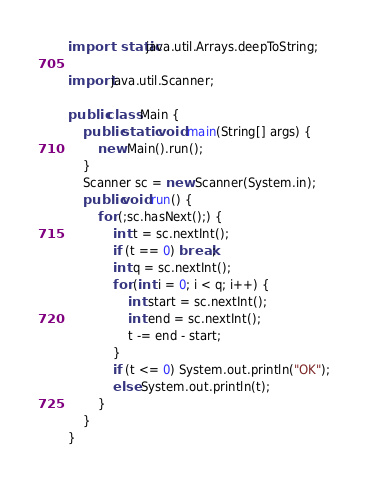Convert code to text. <code><loc_0><loc_0><loc_500><loc_500><_Java_>
import static java.util.Arrays.deepToString;

import java.util.Scanner;

public class Main {
	public static void main(String[] args) {
		new Main().run();
	}
	Scanner sc = new Scanner(System.in);
	public void run() {
		for (;sc.hasNext();) {
			int t = sc.nextInt();
			if (t == 0) break;
			int q = sc.nextInt();
			for (int i = 0; i < q; i++) {
				int start = sc.nextInt();
				int end = sc.nextInt();
				t -= end - start;
			}
			if (t <= 0) System.out.println("OK");
			else System.out.println(t);
		}
	}
}</code> 